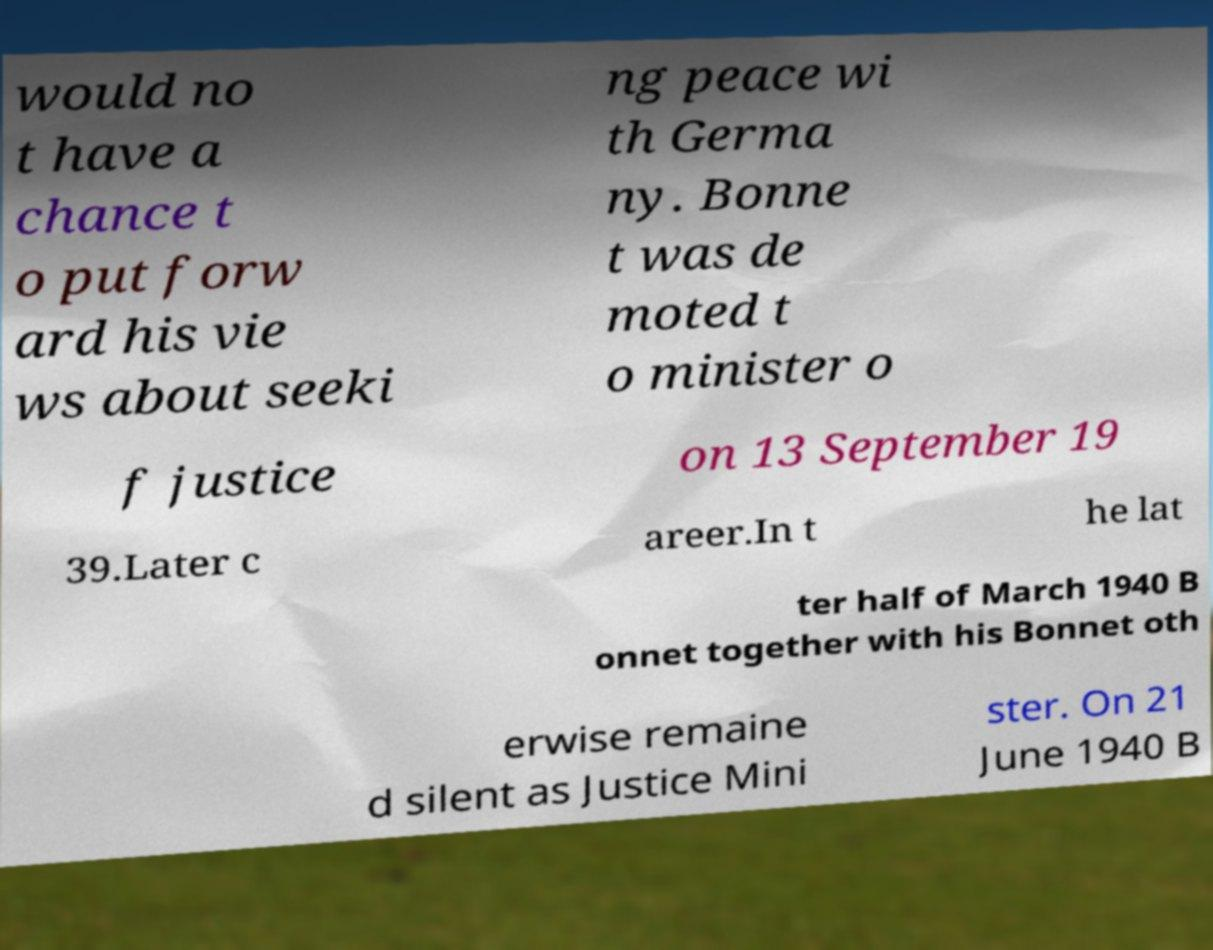Can you read and provide the text displayed in the image?This photo seems to have some interesting text. Can you extract and type it out for me? would no t have a chance t o put forw ard his vie ws about seeki ng peace wi th Germa ny. Bonne t was de moted t o minister o f justice on 13 September 19 39.Later c areer.In t he lat ter half of March 1940 B onnet together with his Bonnet oth erwise remaine d silent as Justice Mini ster. On 21 June 1940 B 